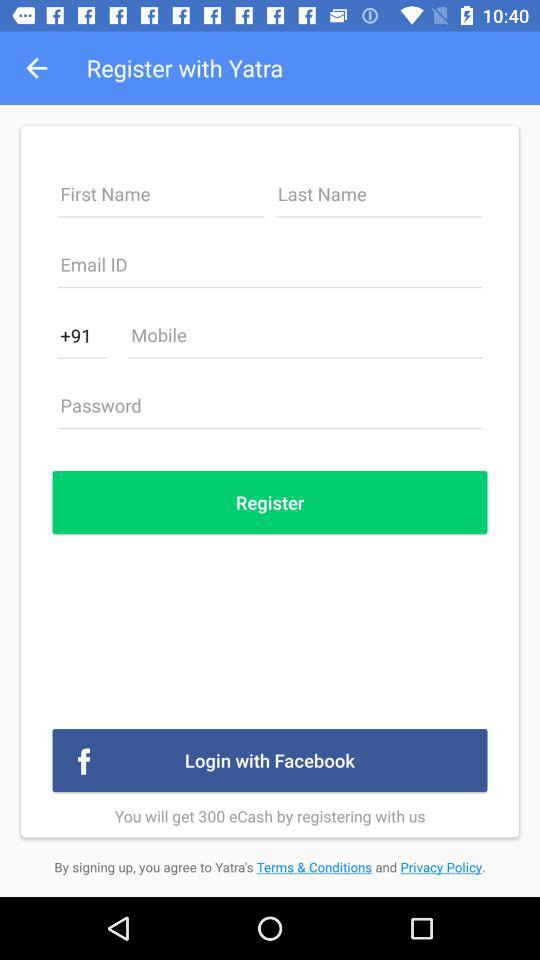What is the other option to login? The other option to login is "Facebook". 